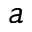<formula> <loc_0><loc_0><loc_500><loc_500>a</formula> 